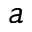<formula> <loc_0><loc_0><loc_500><loc_500>a</formula> 